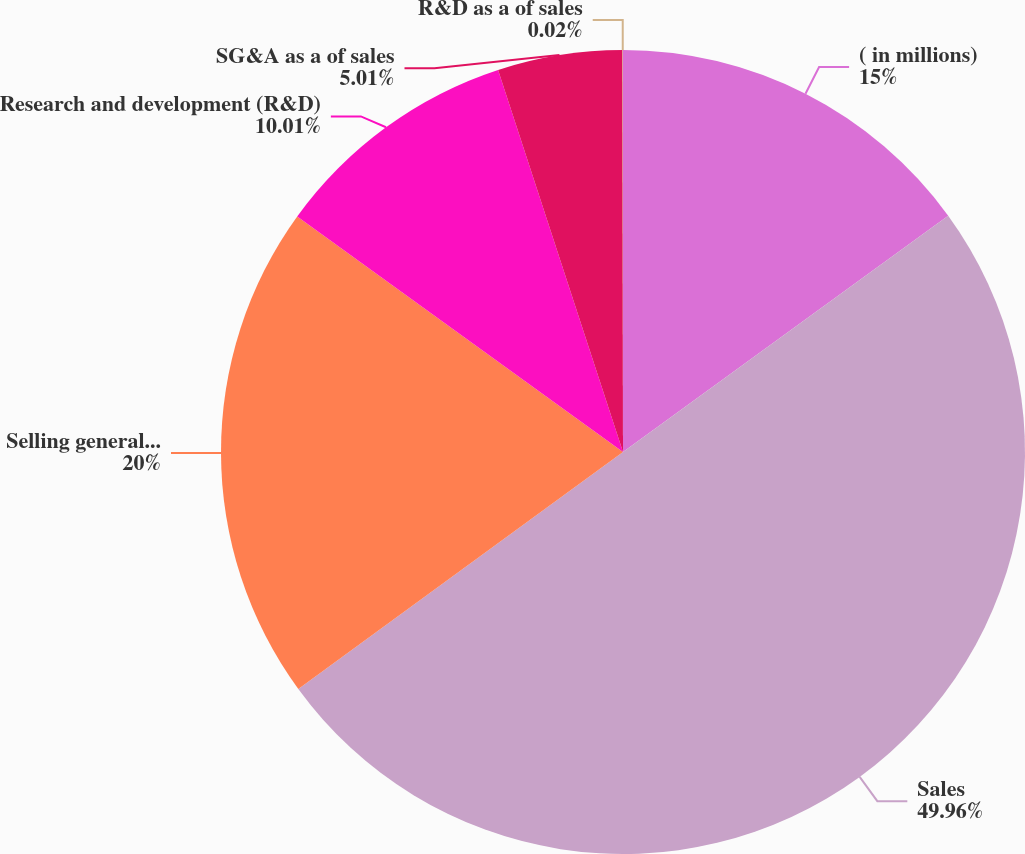Convert chart to OTSL. <chart><loc_0><loc_0><loc_500><loc_500><pie_chart><fcel>( in millions)<fcel>Sales<fcel>Selling general and<fcel>Research and development (R&D)<fcel>SG&A as a of sales<fcel>R&D as a of sales<nl><fcel>15.0%<fcel>49.97%<fcel>20.0%<fcel>10.01%<fcel>5.01%<fcel>0.02%<nl></chart> 